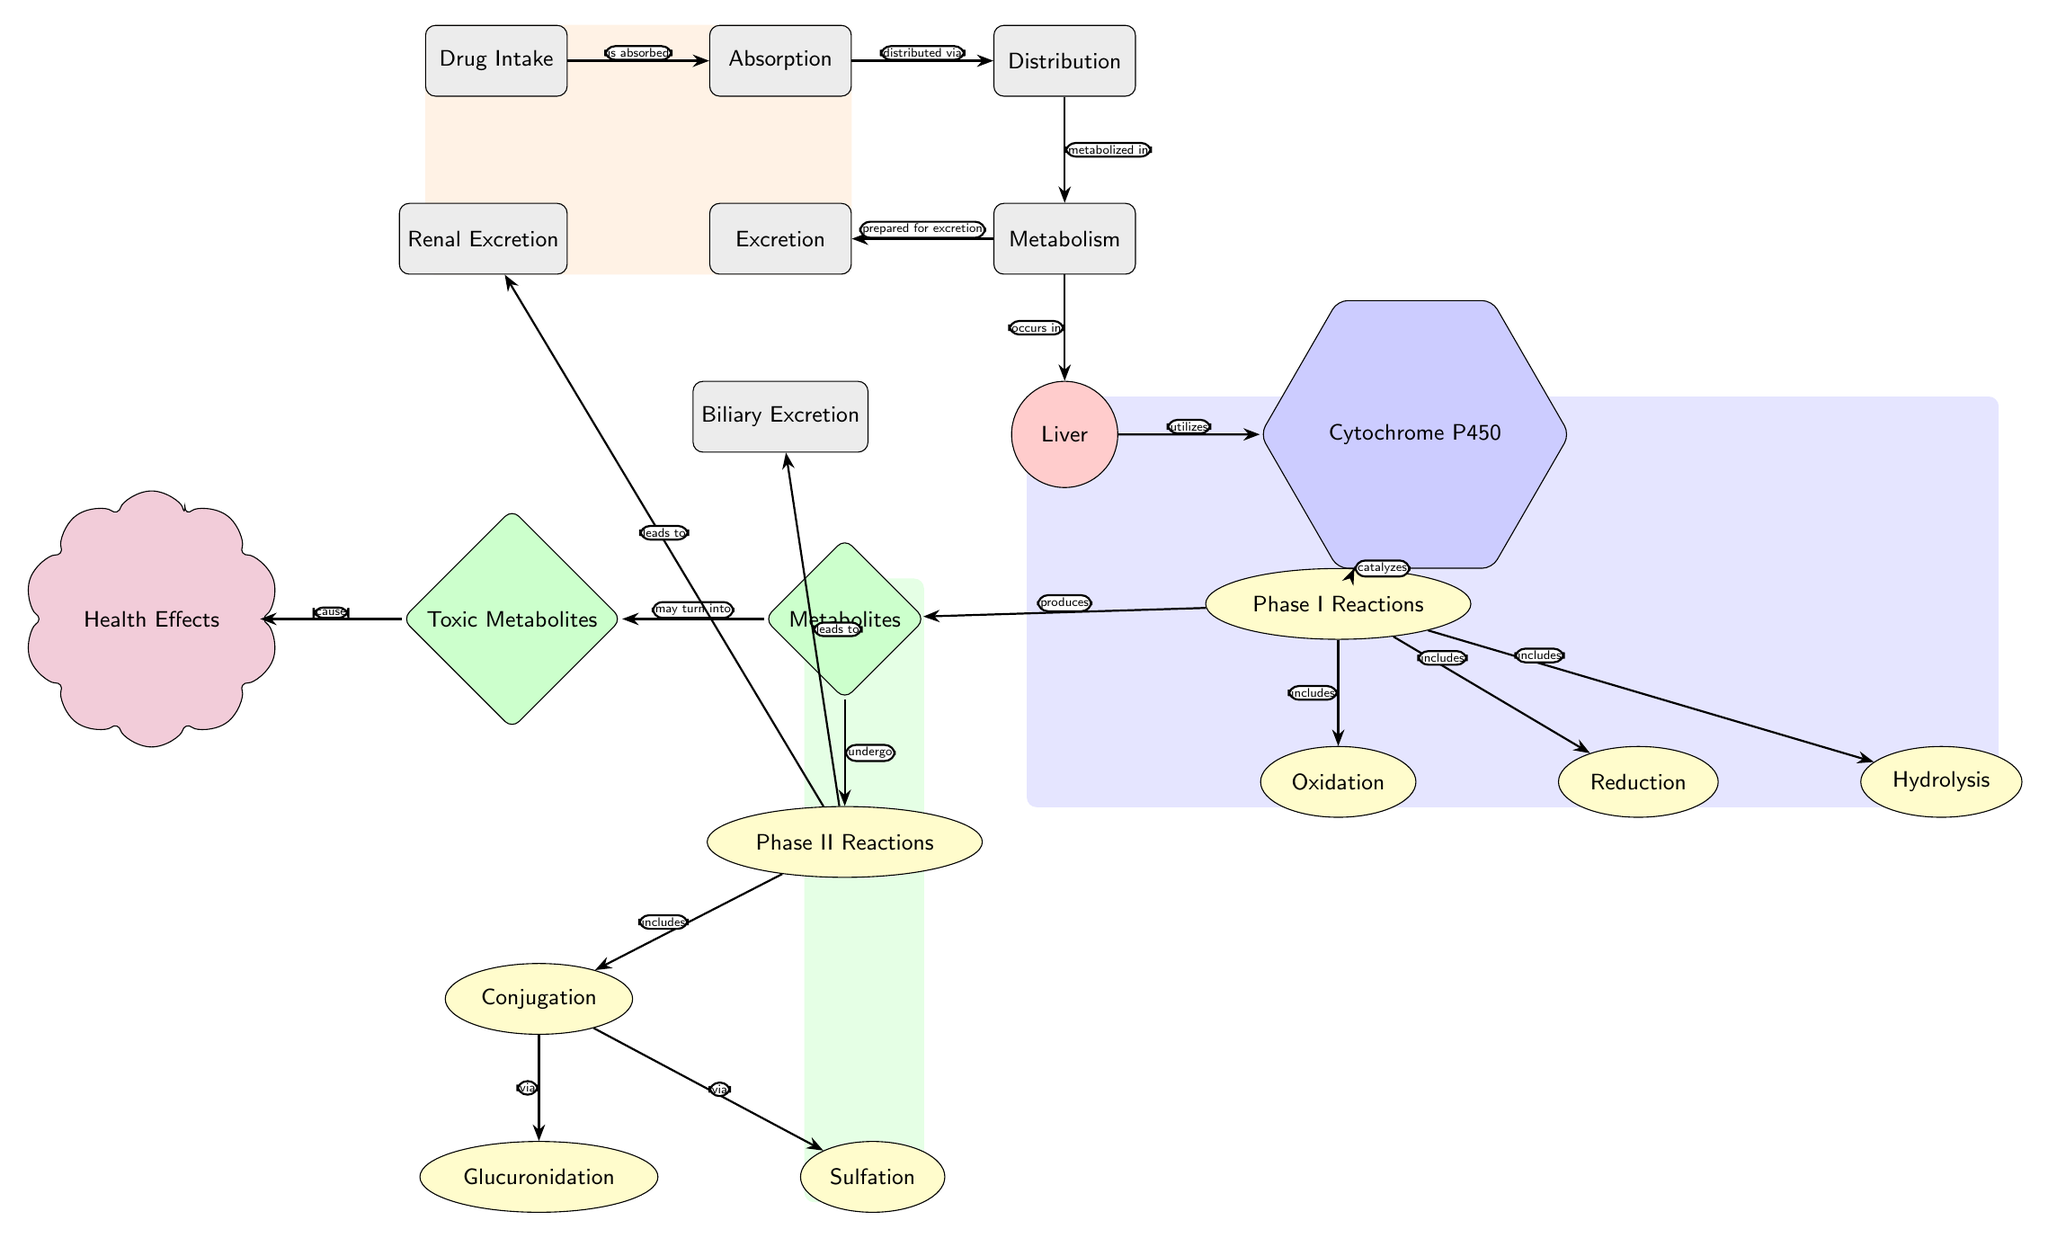What is the first process in the drug metabolism pathway? The diagram indicates that the first step in the pathway is "Drug Intake." This process is represented as the leftmost node.
Answer: Drug Intake How many reactions are included in Phase I reactions? The diagram clearly shows three reactions under Phase I: Oxidation, Reduction, and Hydrolysis. Therefore, we count these reactions to find the total.
Answer: 3 What is produced during Phase I reactions? According to the diagram, Phase I reactions lead to the production of "Metabolites." This is clearly indicated as a node directly connected to Phase I reactions with an arrow labeled "produces."
Answer: Metabolites Which organ is primarily involved in metabolism in this diagram? The diagram specifies that metabolism occurs in the "Liver," which is designated as an organ node in the diagram.
Answer: Liver What health effects result from toxic metabolites? The diagram shows a direct connection between "Toxic Metabolites" and "Health Effects," indicating that toxic metabolites cause adverse health effects.
Answer: Cause What happens to metabolites after they undergo Phase II reactions? The diagram demonstrates that after Phase II reactions, metabolites lead to both "Renal Excretion" and "Biliary Excretion," as indicated by the arrows leading from the Phase II reactions to these processes.
Answer: Lead to Where do Phase II reactions occur in relation to Phase I reactions? The diagram shows that Phase II reactions come after Metabolites, which are produced from Phase I reactions, indicating that they are sequential. This indicates a flow from Phase I to Phase II, establishing the order.
Answer: After Which enzyme is utilized in the metabolism process? The diagram identifies "Cytochrome P450" as the enzyme that catalyzes reactions in the metabolism process, specifically indicated by the connection from the liver node.
Answer: Cytochrome P450 